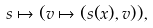Convert formula to latex. <formula><loc_0><loc_0><loc_500><loc_500>s \mapsto ( v \mapsto ( s ( x ) , v ) ) ,</formula> 